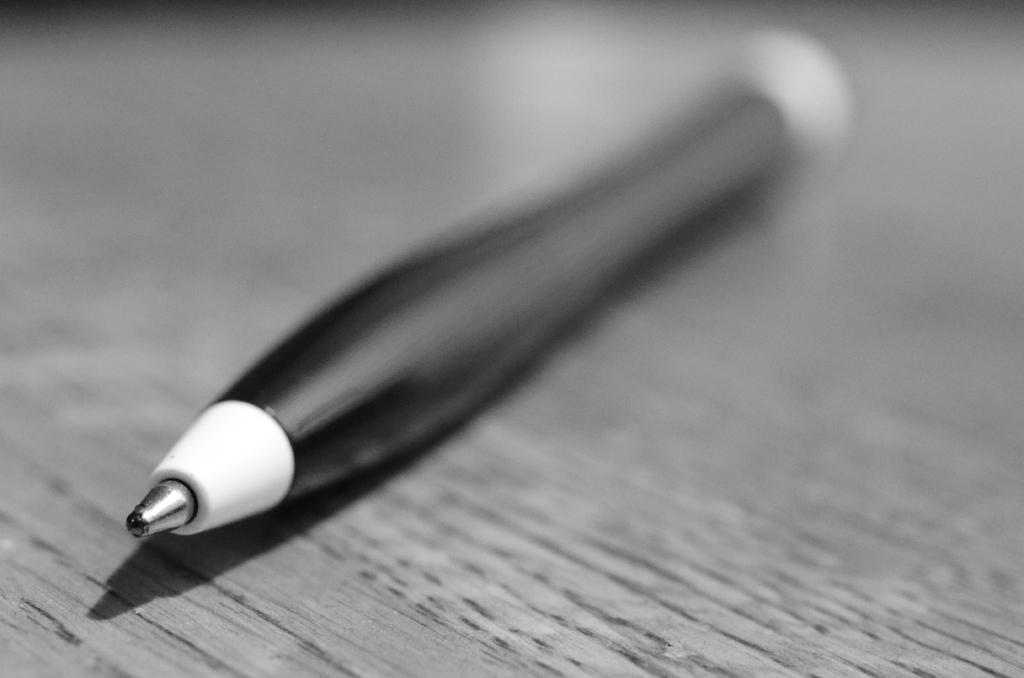What object can be seen in the image? There is a pen in the image. Where is the pen located? The pen is on a wooden board. What is the color scheme of the image? The image is in black and white. What type of servant is depicted in the image? There is no servant present in the image; it only features a pen on a wooden board. What season is it in the image? The image is in black and white, so it is not possible to determine the season from the image. 